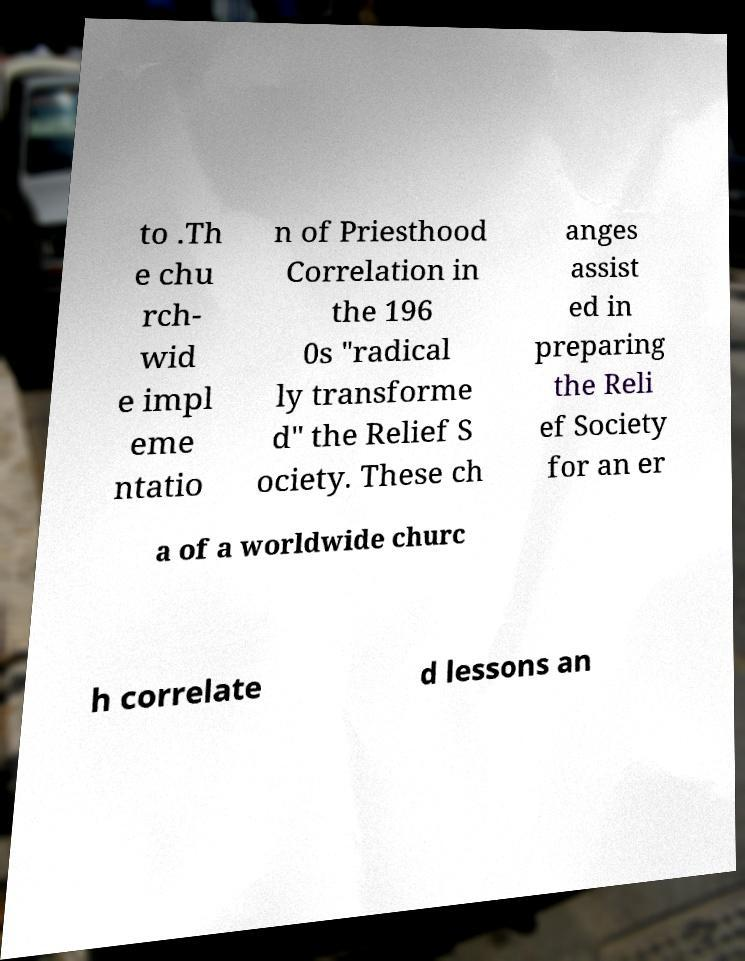What messages or text are displayed in this image? I need them in a readable, typed format. to .Th e chu rch- wid e impl eme ntatio n of Priesthood Correlation in the 196 0s "radical ly transforme d" the Relief S ociety. These ch anges assist ed in preparing the Reli ef Society for an er a of a worldwide churc h correlate d lessons an 